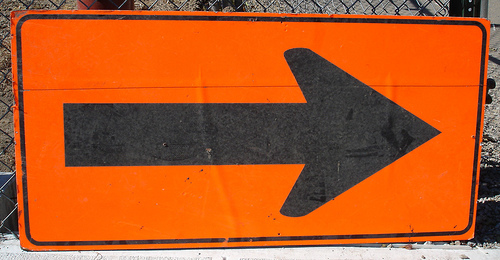<image>
Is there a arrow in front of the sign? No. The arrow is not in front of the sign. The spatial positioning shows a different relationship between these objects. 